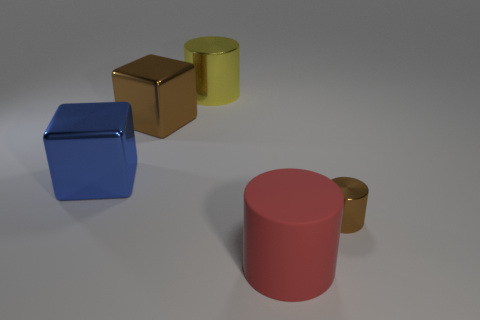Are there the same number of large yellow shiny cylinders that are left of the yellow cylinder and brown metallic objects that are in front of the blue thing?
Ensure brevity in your answer.  No. Is the big brown thing made of the same material as the small brown cylinder?
Keep it short and to the point. Yes. What number of cyan things are large cubes or rubber balls?
Make the answer very short. 0. How many big yellow metallic things are the same shape as the red matte object?
Your answer should be compact. 1. What material is the big brown cube?
Keep it short and to the point. Metal. Is the number of big matte objects that are on the right side of the red matte cylinder the same as the number of big brown shiny objects?
Your response must be concise. No. What is the shape of the brown thing that is the same size as the rubber cylinder?
Your answer should be very brief. Cube. There is a metal cylinder that is behind the tiny object; is there a large cylinder that is to the right of it?
Provide a short and direct response. Yes. What number of small objects are either red cylinders or blue matte cubes?
Your answer should be very brief. 0. Is there a brown shiny cylinder that has the same size as the rubber thing?
Offer a very short reply. No. 